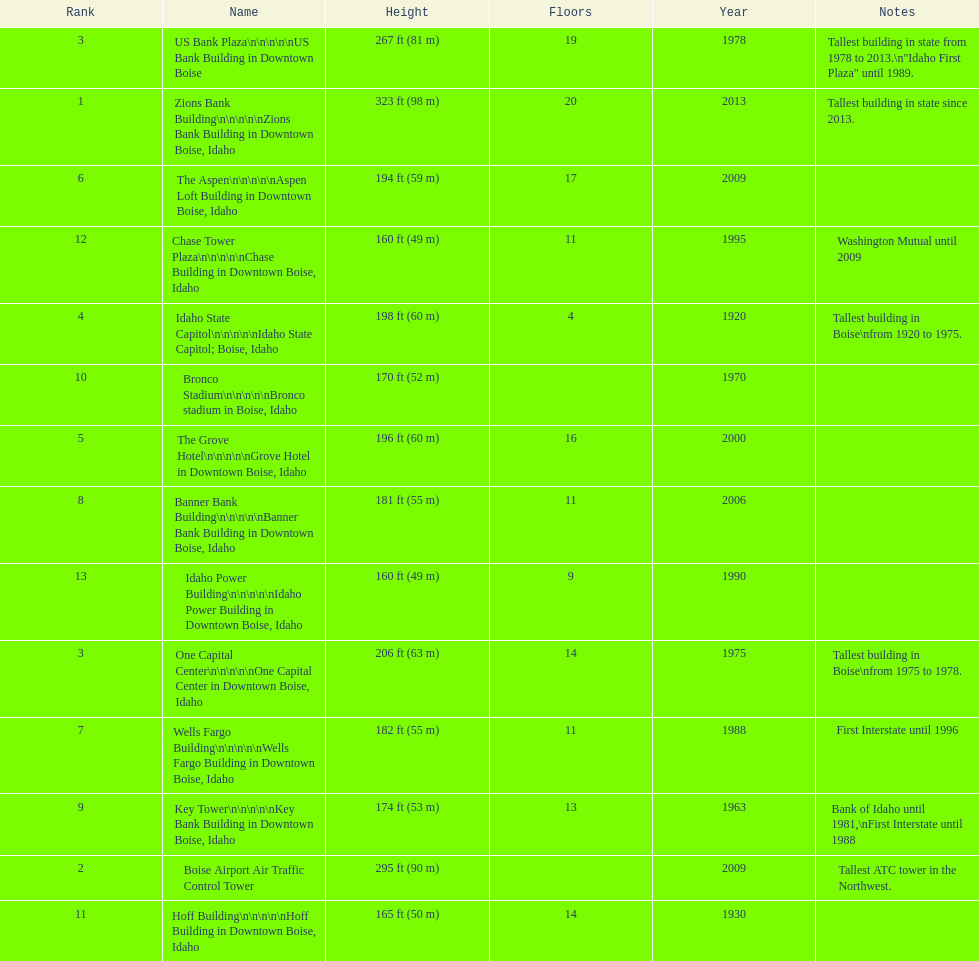What is the number of floors of the oldest building? 4. 